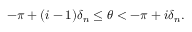Convert formula to latex. <formula><loc_0><loc_0><loc_500><loc_500>- \pi + ( i - 1 ) \delta _ { n } \leq \theta < - \pi + i \delta _ { n } .</formula> 